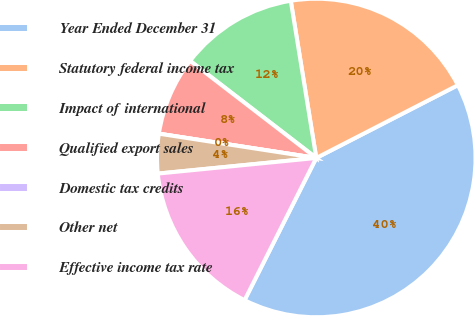Convert chart to OTSL. <chart><loc_0><loc_0><loc_500><loc_500><pie_chart><fcel>Year Ended December 31<fcel>Statutory federal income tax<fcel>Impact of international<fcel>Qualified export sales<fcel>Domestic tax credits<fcel>Other net<fcel>Effective income tax rate<nl><fcel>39.99%<fcel>20.0%<fcel>12.0%<fcel>8.0%<fcel>0.0%<fcel>4.0%<fcel>16.0%<nl></chart> 